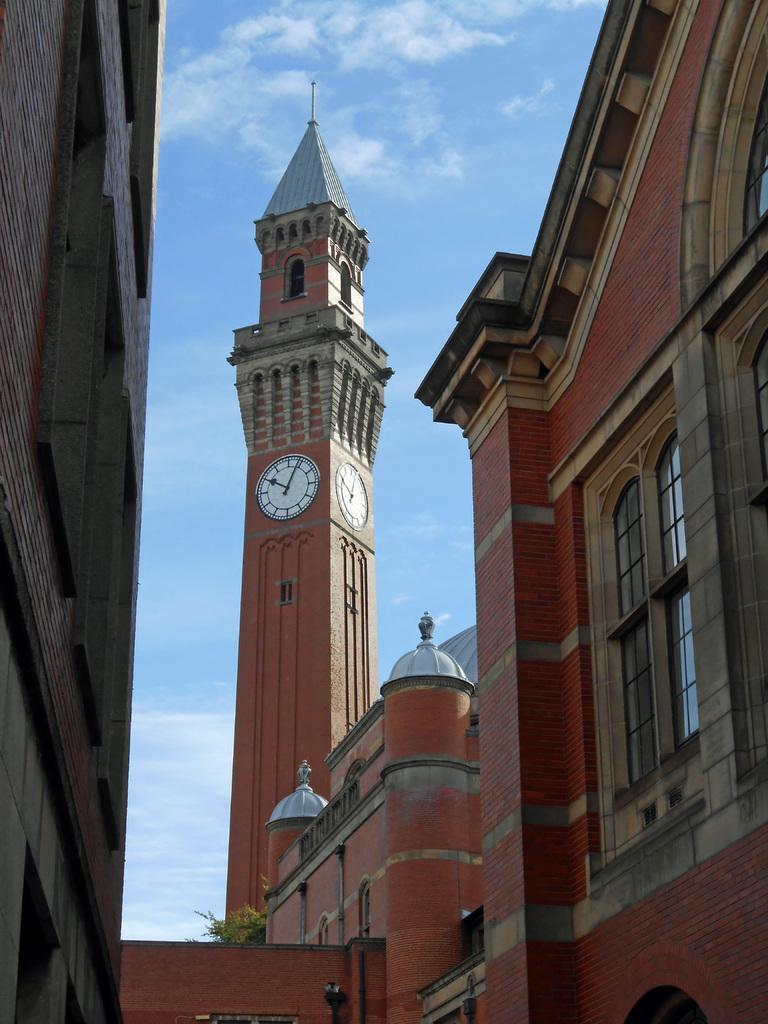In one or two sentences, can you explain what this image depicts? In this picture we can see a clock tower. These are the buildings. And on the background there is a sky with clouds. 